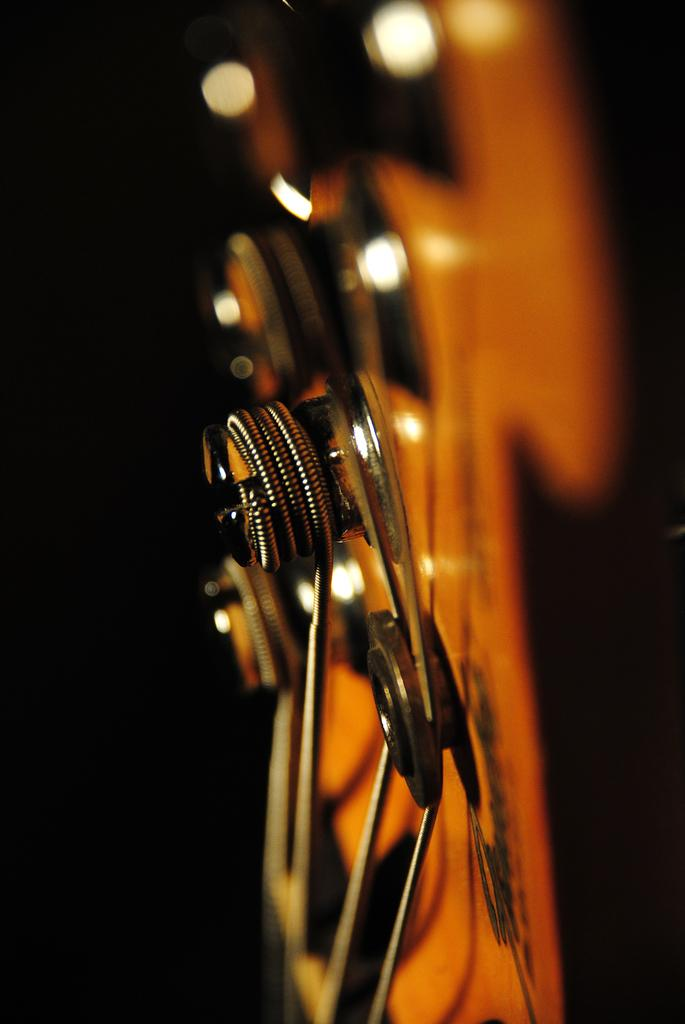What can be seen in the image? There is an object in the image. How does the object in the image contribute to the person's debt? There is no information about debt or a person in the image, so we cannot determine any connection between the object and debt. 